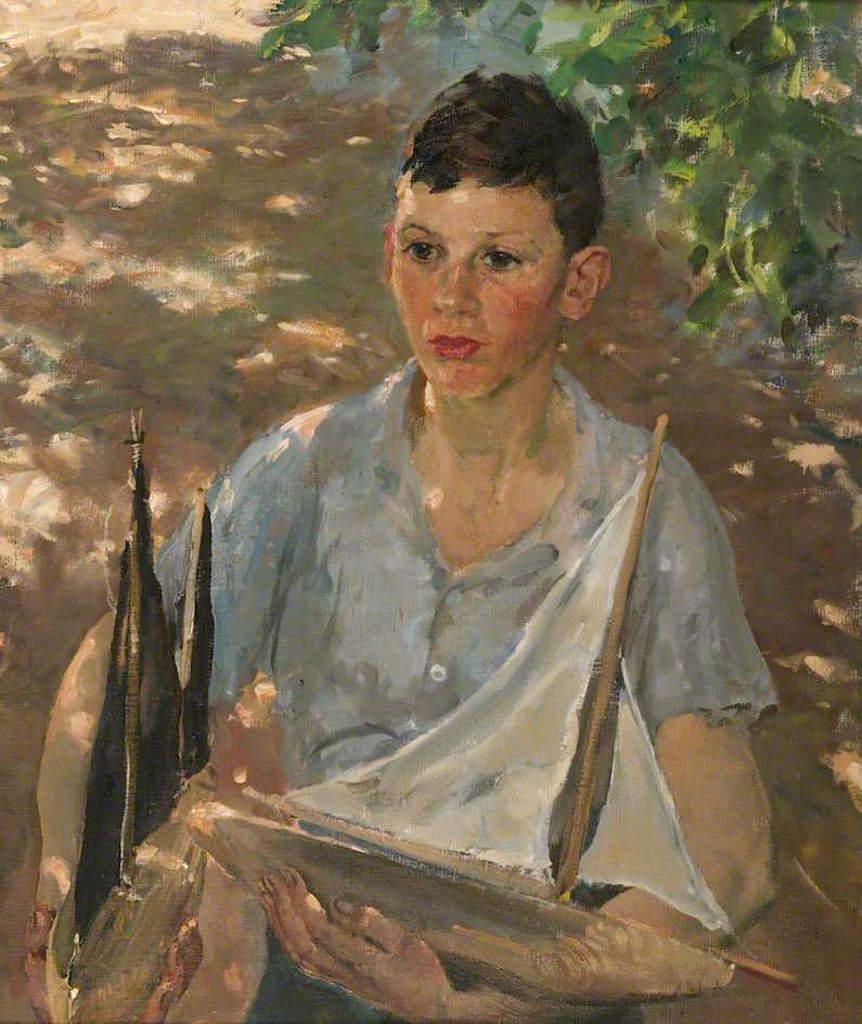In one or two sentences, can you explain what this image depicts? This is an edited image and cartoon image in which in the front there is a boy holding an objects in his hand, which are brown and white in colour. In the background there are leaves. 